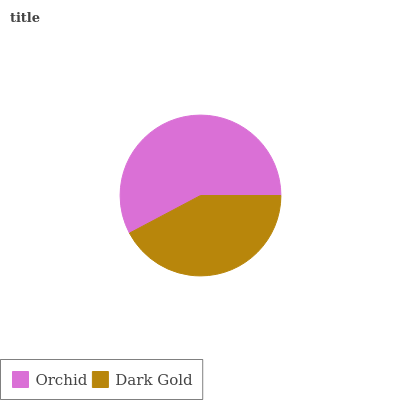Is Dark Gold the minimum?
Answer yes or no. Yes. Is Orchid the maximum?
Answer yes or no. Yes. Is Dark Gold the maximum?
Answer yes or no. No. Is Orchid greater than Dark Gold?
Answer yes or no. Yes. Is Dark Gold less than Orchid?
Answer yes or no. Yes. Is Dark Gold greater than Orchid?
Answer yes or no. No. Is Orchid less than Dark Gold?
Answer yes or no. No. Is Orchid the high median?
Answer yes or no. Yes. Is Dark Gold the low median?
Answer yes or no. Yes. Is Dark Gold the high median?
Answer yes or no. No. Is Orchid the low median?
Answer yes or no. No. 